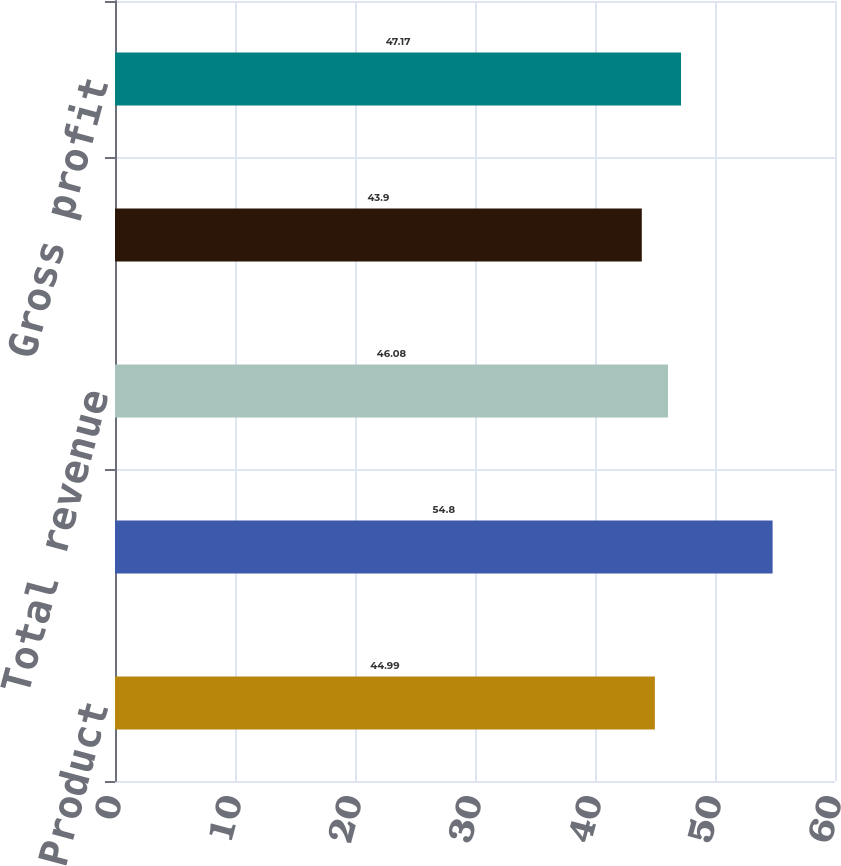Convert chart. <chart><loc_0><loc_0><loc_500><loc_500><bar_chart><fcel>Product<fcel>Service<fcel>Total revenue<fcel>Total cost of revenue<fcel>Gross profit<nl><fcel>44.99<fcel>54.8<fcel>46.08<fcel>43.9<fcel>47.17<nl></chart> 